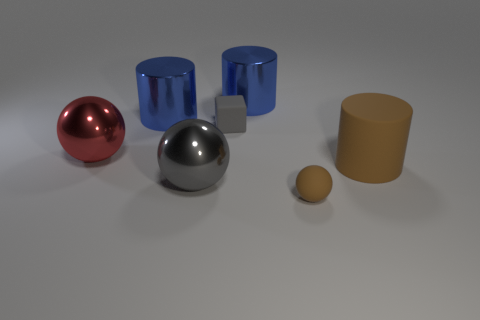Is there a large matte cylinder?
Your answer should be compact. Yes. There is a shiny cylinder that is behind the blue thing left of the big gray metal thing; what size is it?
Offer a terse response. Large. Is the number of red balls on the left side of the small brown rubber ball greater than the number of metallic cylinders to the left of the big red metallic ball?
Ensure brevity in your answer.  Yes. How many cubes are tiny brown things or large brown objects?
Give a very brief answer. 0. Is there anything else that is the same size as the matte cylinder?
Provide a succinct answer. Yes. Does the large metallic thing that is in front of the red sphere have the same shape as the red thing?
Ensure brevity in your answer.  Yes. What color is the big matte cylinder?
Your response must be concise. Brown. What color is the other metallic object that is the same shape as the big gray metal object?
Provide a short and direct response. Red. How many metal objects have the same shape as the big matte thing?
Your answer should be very brief. 2. How many things are small matte cubes or brown objects that are left of the big brown matte thing?
Provide a short and direct response. 2. 